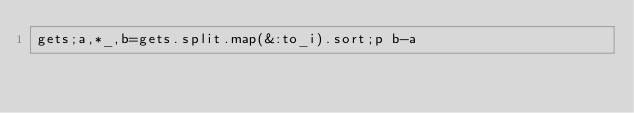<code> <loc_0><loc_0><loc_500><loc_500><_Ruby_>gets;a,*_,b=gets.split.map(&:to_i).sort;p b-a                                                                                                  </code> 